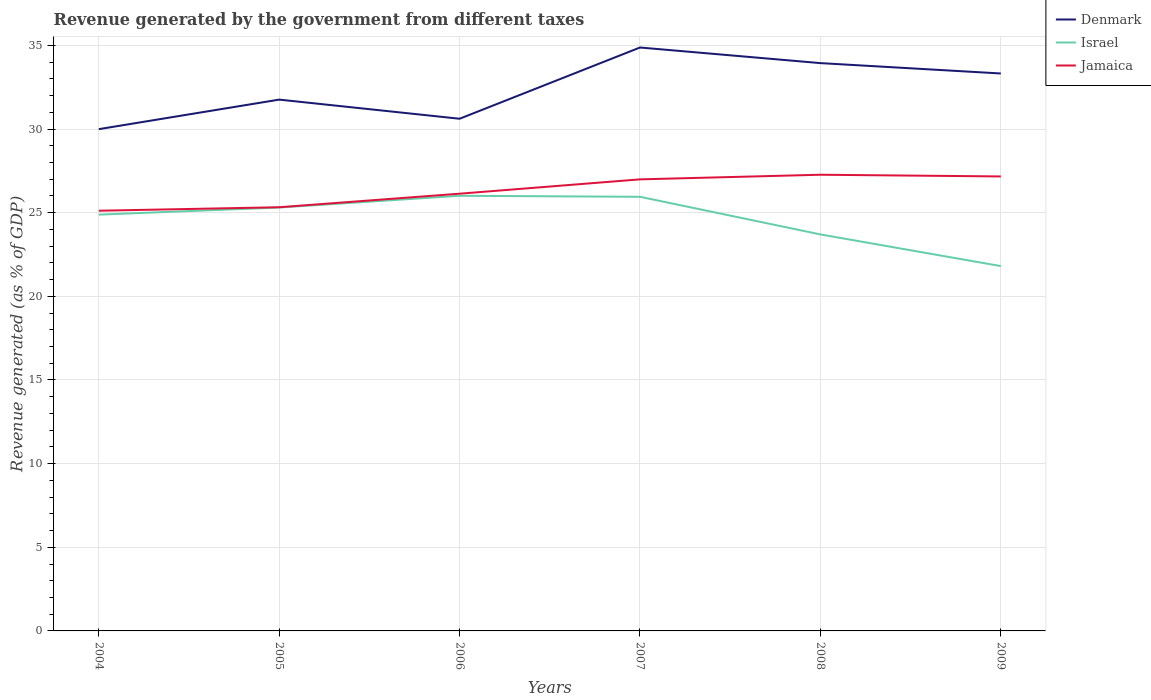How many different coloured lines are there?
Provide a succinct answer. 3. Across all years, what is the maximum revenue generated by the government in Denmark?
Your response must be concise. 30. In which year was the revenue generated by the government in Jamaica maximum?
Ensure brevity in your answer.  2004. What is the total revenue generated by the government in Denmark in the graph?
Make the answer very short. -3.33. What is the difference between the highest and the second highest revenue generated by the government in Jamaica?
Provide a succinct answer. 2.15. Is the revenue generated by the government in Jamaica strictly greater than the revenue generated by the government in Israel over the years?
Provide a succinct answer. No. Are the values on the major ticks of Y-axis written in scientific E-notation?
Make the answer very short. No. Where does the legend appear in the graph?
Ensure brevity in your answer.  Top right. How are the legend labels stacked?
Your response must be concise. Vertical. What is the title of the graph?
Make the answer very short. Revenue generated by the government from different taxes. What is the label or title of the Y-axis?
Ensure brevity in your answer.  Revenue generated (as % of GDP). What is the Revenue generated (as % of GDP) of Denmark in 2004?
Offer a very short reply. 30. What is the Revenue generated (as % of GDP) of Israel in 2004?
Offer a very short reply. 24.89. What is the Revenue generated (as % of GDP) of Jamaica in 2004?
Give a very brief answer. 25.12. What is the Revenue generated (as % of GDP) of Denmark in 2005?
Offer a terse response. 31.76. What is the Revenue generated (as % of GDP) of Israel in 2005?
Keep it short and to the point. 25.31. What is the Revenue generated (as % of GDP) in Jamaica in 2005?
Provide a short and direct response. 25.33. What is the Revenue generated (as % of GDP) in Denmark in 2006?
Ensure brevity in your answer.  30.62. What is the Revenue generated (as % of GDP) in Israel in 2006?
Your response must be concise. 26.01. What is the Revenue generated (as % of GDP) in Jamaica in 2006?
Offer a very short reply. 26.14. What is the Revenue generated (as % of GDP) of Denmark in 2007?
Keep it short and to the point. 34.88. What is the Revenue generated (as % of GDP) in Israel in 2007?
Give a very brief answer. 25.95. What is the Revenue generated (as % of GDP) in Jamaica in 2007?
Provide a succinct answer. 26.99. What is the Revenue generated (as % of GDP) of Denmark in 2008?
Keep it short and to the point. 33.94. What is the Revenue generated (as % of GDP) in Israel in 2008?
Your answer should be compact. 23.7. What is the Revenue generated (as % of GDP) of Jamaica in 2008?
Your answer should be compact. 27.27. What is the Revenue generated (as % of GDP) in Denmark in 2009?
Give a very brief answer. 33.32. What is the Revenue generated (as % of GDP) of Israel in 2009?
Your answer should be compact. 21.81. What is the Revenue generated (as % of GDP) of Jamaica in 2009?
Keep it short and to the point. 27.17. Across all years, what is the maximum Revenue generated (as % of GDP) in Denmark?
Provide a succinct answer. 34.88. Across all years, what is the maximum Revenue generated (as % of GDP) of Israel?
Give a very brief answer. 26.01. Across all years, what is the maximum Revenue generated (as % of GDP) of Jamaica?
Keep it short and to the point. 27.27. Across all years, what is the minimum Revenue generated (as % of GDP) of Denmark?
Your answer should be very brief. 30. Across all years, what is the minimum Revenue generated (as % of GDP) of Israel?
Give a very brief answer. 21.81. Across all years, what is the minimum Revenue generated (as % of GDP) of Jamaica?
Keep it short and to the point. 25.12. What is the total Revenue generated (as % of GDP) in Denmark in the graph?
Ensure brevity in your answer.  194.52. What is the total Revenue generated (as % of GDP) in Israel in the graph?
Give a very brief answer. 147.67. What is the total Revenue generated (as % of GDP) of Jamaica in the graph?
Provide a succinct answer. 158.02. What is the difference between the Revenue generated (as % of GDP) in Denmark in 2004 and that in 2005?
Ensure brevity in your answer.  -1.77. What is the difference between the Revenue generated (as % of GDP) of Israel in 2004 and that in 2005?
Provide a short and direct response. -0.42. What is the difference between the Revenue generated (as % of GDP) in Jamaica in 2004 and that in 2005?
Make the answer very short. -0.21. What is the difference between the Revenue generated (as % of GDP) of Denmark in 2004 and that in 2006?
Give a very brief answer. -0.62. What is the difference between the Revenue generated (as % of GDP) of Israel in 2004 and that in 2006?
Give a very brief answer. -1.13. What is the difference between the Revenue generated (as % of GDP) of Jamaica in 2004 and that in 2006?
Ensure brevity in your answer.  -1.02. What is the difference between the Revenue generated (as % of GDP) of Denmark in 2004 and that in 2007?
Make the answer very short. -4.88. What is the difference between the Revenue generated (as % of GDP) of Israel in 2004 and that in 2007?
Your answer should be compact. -1.07. What is the difference between the Revenue generated (as % of GDP) in Jamaica in 2004 and that in 2007?
Offer a terse response. -1.87. What is the difference between the Revenue generated (as % of GDP) of Denmark in 2004 and that in 2008?
Your answer should be compact. -3.95. What is the difference between the Revenue generated (as % of GDP) of Israel in 2004 and that in 2008?
Provide a succinct answer. 1.18. What is the difference between the Revenue generated (as % of GDP) in Jamaica in 2004 and that in 2008?
Your answer should be very brief. -2.15. What is the difference between the Revenue generated (as % of GDP) in Denmark in 2004 and that in 2009?
Provide a succinct answer. -3.33. What is the difference between the Revenue generated (as % of GDP) in Israel in 2004 and that in 2009?
Offer a terse response. 3.08. What is the difference between the Revenue generated (as % of GDP) in Jamaica in 2004 and that in 2009?
Keep it short and to the point. -2.05. What is the difference between the Revenue generated (as % of GDP) of Denmark in 2005 and that in 2006?
Offer a very short reply. 1.14. What is the difference between the Revenue generated (as % of GDP) of Israel in 2005 and that in 2006?
Offer a terse response. -0.7. What is the difference between the Revenue generated (as % of GDP) of Jamaica in 2005 and that in 2006?
Make the answer very short. -0.81. What is the difference between the Revenue generated (as % of GDP) in Denmark in 2005 and that in 2007?
Your answer should be compact. -3.12. What is the difference between the Revenue generated (as % of GDP) in Israel in 2005 and that in 2007?
Provide a succinct answer. -0.64. What is the difference between the Revenue generated (as % of GDP) in Jamaica in 2005 and that in 2007?
Keep it short and to the point. -1.67. What is the difference between the Revenue generated (as % of GDP) in Denmark in 2005 and that in 2008?
Keep it short and to the point. -2.18. What is the difference between the Revenue generated (as % of GDP) of Israel in 2005 and that in 2008?
Your answer should be compact. 1.61. What is the difference between the Revenue generated (as % of GDP) in Jamaica in 2005 and that in 2008?
Keep it short and to the point. -1.94. What is the difference between the Revenue generated (as % of GDP) in Denmark in 2005 and that in 2009?
Offer a very short reply. -1.56. What is the difference between the Revenue generated (as % of GDP) of Israel in 2005 and that in 2009?
Provide a succinct answer. 3.5. What is the difference between the Revenue generated (as % of GDP) of Jamaica in 2005 and that in 2009?
Your answer should be very brief. -1.84. What is the difference between the Revenue generated (as % of GDP) in Denmark in 2006 and that in 2007?
Offer a very short reply. -4.26. What is the difference between the Revenue generated (as % of GDP) of Israel in 2006 and that in 2007?
Provide a succinct answer. 0.06. What is the difference between the Revenue generated (as % of GDP) in Jamaica in 2006 and that in 2007?
Offer a very short reply. -0.86. What is the difference between the Revenue generated (as % of GDP) in Denmark in 2006 and that in 2008?
Give a very brief answer. -3.33. What is the difference between the Revenue generated (as % of GDP) in Israel in 2006 and that in 2008?
Provide a short and direct response. 2.31. What is the difference between the Revenue generated (as % of GDP) of Jamaica in 2006 and that in 2008?
Your answer should be compact. -1.13. What is the difference between the Revenue generated (as % of GDP) of Denmark in 2006 and that in 2009?
Provide a succinct answer. -2.71. What is the difference between the Revenue generated (as % of GDP) in Israel in 2006 and that in 2009?
Your answer should be very brief. 4.2. What is the difference between the Revenue generated (as % of GDP) in Jamaica in 2006 and that in 2009?
Keep it short and to the point. -1.03. What is the difference between the Revenue generated (as % of GDP) in Denmark in 2007 and that in 2008?
Your response must be concise. 0.93. What is the difference between the Revenue generated (as % of GDP) of Israel in 2007 and that in 2008?
Your answer should be compact. 2.25. What is the difference between the Revenue generated (as % of GDP) of Jamaica in 2007 and that in 2008?
Give a very brief answer. -0.28. What is the difference between the Revenue generated (as % of GDP) of Denmark in 2007 and that in 2009?
Your answer should be very brief. 1.55. What is the difference between the Revenue generated (as % of GDP) in Israel in 2007 and that in 2009?
Offer a very short reply. 4.14. What is the difference between the Revenue generated (as % of GDP) of Jamaica in 2007 and that in 2009?
Offer a terse response. -0.17. What is the difference between the Revenue generated (as % of GDP) of Denmark in 2008 and that in 2009?
Give a very brief answer. 0.62. What is the difference between the Revenue generated (as % of GDP) in Israel in 2008 and that in 2009?
Offer a terse response. 1.89. What is the difference between the Revenue generated (as % of GDP) of Jamaica in 2008 and that in 2009?
Keep it short and to the point. 0.1. What is the difference between the Revenue generated (as % of GDP) in Denmark in 2004 and the Revenue generated (as % of GDP) in Israel in 2005?
Make the answer very short. 4.69. What is the difference between the Revenue generated (as % of GDP) in Denmark in 2004 and the Revenue generated (as % of GDP) in Jamaica in 2005?
Your answer should be very brief. 4.67. What is the difference between the Revenue generated (as % of GDP) of Israel in 2004 and the Revenue generated (as % of GDP) of Jamaica in 2005?
Offer a very short reply. -0.44. What is the difference between the Revenue generated (as % of GDP) in Denmark in 2004 and the Revenue generated (as % of GDP) in Israel in 2006?
Your response must be concise. 3.98. What is the difference between the Revenue generated (as % of GDP) of Denmark in 2004 and the Revenue generated (as % of GDP) of Jamaica in 2006?
Provide a short and direct response. 3.86. What is the difference between the Revenue generated (as % of GDP) of Israel in 2004 and the Revenue generated (as % of GDP) of Jamaica in 2006?
Your answer should be very brief. -1.25. What is the difference between the Revenue generated (as % of GDP) in Denmark in 2004 and the Revenue generated (as % of GDP) in Israel in 2007?
Provide a succinct answer. 4.04. What is the difference between the Revenue generated (as % of GDP) in Denmark in 2004 and the Revenue generated (as % of GDP) in Jamaica in 2007?
Your answer should be compact. 3. What is the difference between the Revenue generated (as % of GDP) in Israel in 2004 and the Revenue generated (as % of GDP) in Jamaica in 2007?
Offer a terse response. -2.11. What is the difference between the Revenue generated (as % of GDP) of Denmark in 2004 and the Revenue generated (as % of GDP) of Israel in 2008?
Provide a short and direct response. 6.29. What is the difference between the Revenue generated (as % of GDP) of Denmark in 2004 and the Revenue generated (as % of GDP) of Jamaica in 2008?
Provide a succinct answer. 2.72. What is the difference between the Revenue generated (as % of GDP) in Israel in 2004 and the Revenue generated (as % of GDP) in Jamaica in 2008?
Offer a very short reply. -2.39. What is the difference between the Revenue generated (as % of GDP) of Denmark in 2004 and the Revenue generated (as % of GDP) of Israel in 2009?
Your answer should be compact. 8.19. What is the difference between the Revenue generated (as % of GDP) of Denmark in 2004 and the Revenue generated (as % of GDP) of Jamaica in 2009?
Your answer should be very brief. 2.83. What is the difference between the Revenue generated (as % of GDP) of Israel in 2004 and the Revenue generated (as % of GDP) of Jamaica in 2009?
Make the answer very short. -2.28. What is the difference between the Revenue generated (as % of GDP) of Denmark in 2005 and the Revenue generated (as % of GDP) of Israel in 2006?
Your response must be concise. 5.75. What is the difference between the Revenue generated (as % of GDP) of Denmark in 2005 and the Revenue generated (as % of GDP) of Jamaica in 2006?
Your answer should be very brief. 5.62. What is the difference between the Revenue generated (as % of GDP) in Israel in 2005 and the Revenue generated (as % of GDP) in Jamaica in 2006?
Keep it short and to the point. -0.83. What is the difference between the Revenue generated (as % of GDP) of Denmark in 2005 and the Revenue generated (as % of GDP) of Israel in 2007?
Offer a terse response. 5.81. What is the difference between the Revenue generated (as % of GDP) of Denmark in 2005 and the Revenue generated (as % of GDP) of Jamaica in 2007?
Give a very brief answer. 4.77. What is the difference between the Revenue generated (as % of GDP) of Israel in 2005 and the Revenue generated (as % of GDP) of Jamaica in 2007?
Your response must be concise. -1.68. What is the difference between the Revenue generated (as % of GDP) in Denmark in 2005 and the Revenue generated (as % of GDP) in Israel in 2008?
Your answer should be compact. 8.06. What is the difference between the Revenue generated (as % of GDP) in Denmark in 2005 and the Revenue generated (as % of GDP) in Jamaica in 2008?
Offer a terse response. 4.49. What is the difference between the Revenue generated (as % of GDP) of Israel in 2005 and the Revenue generated (as % of GDP) of Jamaica in 2008?
Offer a terse response. -1.96. What is the difference between the Revenue generated (as % of GDP) of Denmark in 2005 and the Revenue generated (as % of GDP) of Israel in 2009?
Your answer should be very brief. 9.95. What is the difference between the Revenue generated (as % of GDP) of Denmark in 2005 and the Revenue generated (as % of GDP) of Jamaica in 2009?
Your answer should be very brief. 4.59. What is the difference between the Revenue generated (as % of GDP) of Israel in 2005 and the Revenue generated (as % of GDP) of Jamaica in 2009?
Ensure brevity in your answer.  -1.86. What is the difference between the Revenue generated (as % of GDP) in Denmark in 2006 and the Revenue generated (as % of GDP) in Israel in 2007?
Your answer should be compact. 4.67. What is the difference between the Revenue generated (as % of GDP) of Denmark in 2006 and the Revenue generated (as % of GDP) of Jamaica in 2007?
Provide a succinct answer. 3.62. What is the difference between the Revenue generated (as % of GDP) of Israel in 2006 and the Revenue generated (as % of GDP) of Jamaica in 2007?
Your answer should be compact. -0.98. What is the difference between the Revenue generated (as % of GDP) in Denmark in 2006 and the Revenue generated (as % of GDP) in Israel in 2008?
Your answer should be compact. 6.92. What is the difference between the Revenue generated (as % of GDP) in Denmark in 2006 and the Revenue generated (as % of GDP) in Jamaica in 2008?
Your answer should be very brief. 3.35. What is the difference between the Revenue generated (as % of GDP) in Israel in 2006 and the Revenue generated (as % of GDP) in Jamaica in 2008?
Give a very brief answer. -1.26. What is the difference between the Revenue generated (as % of GDP) of Denmark in 2006 and the Revenue generated (as % of GDP) of Israel in 2009?
Offer a very short reply. 8.81. What is the difference between the Revenue generated (as % of GDP) in Denmark in 2006 and the Revenue generated (as % of GDP) in Jamaica in 2009?
Provide a succinct answer. 3.45. What is the difference between the Revenue generated (as % of GDP) in Israel in 2006 and the Revenue generated (as % of GDP) in Jamaica in 2009?
Your answer should be compact. -1.16. What is the difference between the Revenue generated (as % of GDP) in Denmark in 2007 and the Revenue generated (as % of GDP) in Israel in 2008?
Your answer should be compact. 11.17. What is the difference between the Revenue generated (as % of GDP) of Denmark in 2007 and the Revenue generated (as % of GDP) of Jamaica in 2008?
Your answer should be very brief. 7.61. What is the difference between the Revenue generated (as % of GDP) in Israel in 2007 and the Revenue generated (as % of GDP) in Jamaica in 2008?
Your answer should be compact. -1.32. What is the difference between the Revenue generated (as % of GDP) in Denmark in 2007 and the Revenue generated (as % of GDP) in Israel in 2009?
Your response must be concise. 13.07. What is the difference between the Revenue generated (as % of GDP) in Denmark in 2007 and the Revenue generated (as % of GDP) in Jamaica in 2009?
Your response must be concise. 7.71. What is the difference between the Revenue generated (as % of GDP) in Israel in 2007 and the Revenue generated (as % of GDP) in Jamaica in 2009?
Your response must be concise. -1.22. What is the difference between the Revenue generated (as % of GDP) of Denmark in 2008 and the Revenue generated (as % of GDP) of Israel in 2009?
Ensure brevity in your answer.  12.13. What is the difference between the Revenue generated (as % of GDP) of Denmark in 2008 and the Revenue generated (as % of GDP) of Jamaica in 2009?
Provide a succinct answer. 6.77. What is the difference between the Revenue generated (as % of GDP) in Israel in 2008 and the Revenue generated (as % of GDP) in Jamaica in 2009?
Ensure brevity in your answer.  -3.47. What is the average Revenue generated (as % of GDP) of Denmark per year?
Provide a succinct answer. 32.42. What is the average Revenue generated (as % of GDP) of Israel per year?
Ensure brevity in your answer.  24.61. What is the average Revenue generated (as % of GDP) of Jamaica per year?
Provide a short and direct response. 26.34. In the year 2004, what is the difference between the Revenue generated (as % of GDP) of Denmark and Revenue generated (as % of GDP) of Israel?
Provide a succinct answer. 5.11. In the year 2004, what is the difference between the Revenue generated (as % of GDP) in Denmark and Revenue generated (as % of GDP) in Jamaica?
Keep it short and to the point. 4.88. In the year 2004, what is the difference between the Revenue generated (as % of GDP) of Israel and Revenue generated (as % of GDP) of Jamaica?
Keep it short and to the point. -0.23. In the year 2005, what is the difference between the Revenue generated (as % of GDP) in Denmark and Revenue generated (as % of GDP) in Israel?
Your response must be concise. 6.45. In the year 2005, what is the difference between the Revenue generated (as % of GDP) in Denmark and Revenue generated (as % of GDP) in Jamaica?
Your answer should be very brief. 6.43. In the year 2005, what is the difference between the Revenue generated (as % of GDP) in Israel and Revenue generated (as % of GDP) in Jamaica?
Provide a succinct answer. -0.02. In the year 2006, what is the difference between the Revenue generated (as % of GDP) in Denmark and Revenue generated (as % of GDP) in Israel?
Your answer should be very brief. 4.6. In the year 2006, what is the difference between the Revenue generated (as % of GDP) of Denmark and Revenue generated (as % of GDP) of Jamaica?
Your response must be concise. 4.48. In the year 2006, what is the difference between the Revenue generated (as % of GDP) of Israel and Revenue generated (as % of GDP) of Jamaica?
Give a very brief answer. -0.12. In the year 2007, what is the difference between the Revenue generated (as % of GDP) in Denmark and Revenue generated (as % of GDP) in Israel?
Your answer should be very brief. 8.92. In the year 2007, what is the difference between the Revenue generated (as % of GDP) in Denmark and Revenue generated (as % of GDP) in Jamaica?
Keep it short and to the point. 7.88. In the year 2007, what is the difference between the Revenue generated (as % of GDP) of Israel and Revenue generated (as % of GDP) of Jamaica?
Offer a very short reply. -1.04. In the year 2008, what is the difference between the Revenue generated (as % of GDP) of Denmark and Revenue generated (as % of GDP) of Israel?
Offer a very short reply. 10.24. In the year 2008, what is the difference between the Revenue generated (as % of GDP) of Denmark and Revenue generated (as % of GDP) of Jamaica?
Provide a succinct answer. 6.67. In the year 2008, what is the difference between the Revenue generated (as % of GDP) of Israel and Revenue generated (as % of GDP) of Jamaica?
Offer a terse response. -3.57. In the year 2009, what is the difference between the Revenue generated (as % of GDP) of Denmark and Revenue generated (as % of GDP) of Israel?
Offer a very short reply. 11.51. In the year 2009, what is the difference between the Revenue generated (as % of GDP) of Denmark and Revenue generated (as % of GDP) of Jamaica?
Give a very brief answer. 6.15. In the year 2009, what is the difference between the Revenue generated (as % of GDP) in Israel and Revenue generated (as % of GDP) in Jamaica?
Offer a very short reply. -5.36. What is the ratio of the Revenue generated (as % of GDP) in Israel in 2004 to that in 2005?
Your answer should be very brief. 0.98. What is the ratio of the Revenue generated (as % of GDP) in Jamaica in 2004 to that in 2005?
Your answer should be compact. 0.99. What is the ratio of the Revenue generated (as % of GDP) of Denmark in 2004 to that in 2006?
Make the answer very short. 0.98. What is the ratio of the Revenue generated (as % of GDP) of Israel in 2004 to that in 2006?
Keep it short and to the point. 0.96. What is the ratio of the Revenue generated (as % of GDP) in Jamaica in 2004 to that in 2006?
Offer a very short reply. 0.96. What is the ratio of the Revenue generated (as % of GDP) of Denmark in 2004 to that in 2007?
Keep it short and to the point. 0.86. What is the ratio of the Revenue generated (as % of GDP) of Israel in 2004 to that in 2007?
Ensure brevity in your answer.  0.96. What is the ratio of the Revenue generated (as % of GDP) in Jamaica in 2004 to that in 2007?
Give a very brief answer. 0.93. What is the ratio of the Revenue generated (as % of GDP) of Denmark in 2004 to that in 2008?
Keep it short and to the point. 0.88. What is the ratio of the Revenue generated (as % of GDP) in Israel in 2004 to that in 2008?
Give a very brief answer. 1.05. What is the ratio of the Revenue generated (as % of GDP) in Jamaica in 2004 to that in 2008?
Keep it short and to the point. 0.92. What is the ratio of the Revenue generated (as % of GDP) of Denmark in 2004 to that in 2009?
Provide a succinct answer. 0.9. What is the ratio of the Revenue generated (as % of GDP) of Israel in 2004 to that in 2009?
Offer a very short reply. 1.14. What is the ratio of the Revenue generated (as % of GDP) of Jamaica in 2004 to that in 2009?
Offer a terse response. 0.92. What is the ratio of the Revenue generated (as % of GDP) in Denmark in 2005 to that in 2006?
Offer a very short reply. 1.04. What is the ratio of the Revenue generated (as % of GDP) in Israel in 2005 to that in 2006?
Make the answer very short. 0.97. What is the ratio of the Revenue generated (as % of GDP) of Denmark in 2005 to that in 2007?
Give a very brief answer. 0.91. What is the ratio of the Revenue generated (as % of GDP) of Israel in 2005 to that in 2007?
Offer a very short reply. 0.98. What is the ratio of the Revenue generated (as % of GDP) in Jamaica in 2005 to that in 2007?
Offer a very short reply. 0.94. What is the ratio of the Revenue generated (as % of GDP) of Denmark in 2005 to that in 2008?
Your answer should be very brief. 0.94. What is the ratio of the Revenue generated (as % of GDP) of Israel in 2005 to that in 2008?
Give a very brief answer. 1.07. What is the ratio of the Revenue generated (as % of GDP) of Jamaica in 2005 to that in 2008?
Your answer should be very brief. 0.93. What is the ratio of the Revenue generated (as % of GDP) in Denmark in 2005 to that in 2009?
Your response must be concise. 0.95. What is the ratio of the Revenue generated (as % of GDP) in Israel in 2005 to that in 2009?
Provide a succinct answer. 1.16. What is the ratio of the Revenue generated (as % of GDP) of Jamaica in 2005 to that in 2009?
Offer a very short reply. 0.93. What is the ratio of the Revenue generated (as % of GDP) in Denmark in 2006 to that in 2007?
Provide a succinct answer. 0.88. What is the ratio of the Revenue generated (as % of GDP) in Jamaica in 2006 to that in 2007?
Ensure brevity in your answer.  0.97. What is the ratio of the Revenue generated (as % of GDP) of Denmark in 2006 to that in 2008?
Your answer should be very brief. 0.9. What is the ratio of the Revenue generated (as % of GDP) of Israel in 2006 to that in 2008?
Provide a short and direct response. 1.1. What is the ratio of the Revenue generated (as % of GDP) of Jamaica in 2006 to that in 2008?
Make the answer very short. 0.96. What is the ratio of the Revenue generated (as % of GDP) in Denmark in 2006 to that in 2009?
Your response must be concise. 0.92. What is the ratio of the Revenue generated (as % of GDP) of Israel in 2006 to that in 2009?
Provide a succinct answer. 1.19. What is the ratio of the Revenue generated (as % of GDP) of Denmark in 2007 to that in 2008?
Ensure brevity in your answer.  1.03. What is the ratio of the Revenue generated (as % of GDP) of Israel in 2007 to that in 2008?
Your answer should be compact. 1.09. What is the ratio of the Revenue generated (as % of GDP) of Jamaica in 2007 to that in 2008?
Keep it short and to the point. 0.99. What is the ratio of the Revenue generated (as % of GDP) in Denmark in 2007 to that in 2009?
Your answer should be very brief. 1.05. What is the ratio of the Revenue generated (as % of GDP) of Israel in 2007 to that in 2009?
Your response must be concise. 1.19. What is the ratio of the Revenue generated (as % of GDP) of Denmark in 2008 to that in 2009?
Your response must be concise. 1.02. What is the ratio of the Revenue generated (as % of GDP) of Israel in 2008 to that in 2009?
Offer a terse response. 1.09. What is the ratio of the Revenue generated (as % of GDP) of Jamaica in 2008 to that in 2009?
Give a very brief answer. 1. What is the difference between the highest and the second highest Revenue generated (as % of GDP) in Denmark?
Provide a succinct answer. 0.93. What is the difference between the highest and the second highest Revenue generated (as % of GDP) in Israel?
Provide a short and direct response. 0.06. What is the difference between the highest and the second highest Revenue generated (as % of GDP) in Jamaica?
Provide a succinct answer. 0.1. What is the difference between the highest and the lowest Revenue generated (as % of GDP) of Denmark?
Your answer should be compact. 4.88. What is the difference between the highest and the lowest Revenue generated (as % of GDP) in Israel?
Ensure brevity in your answer.  4.2. What is the difference between the highest and the lowest Revenue generated (as % of GDP) in Jamaica?
Provide a short and direct response. 2.15. 